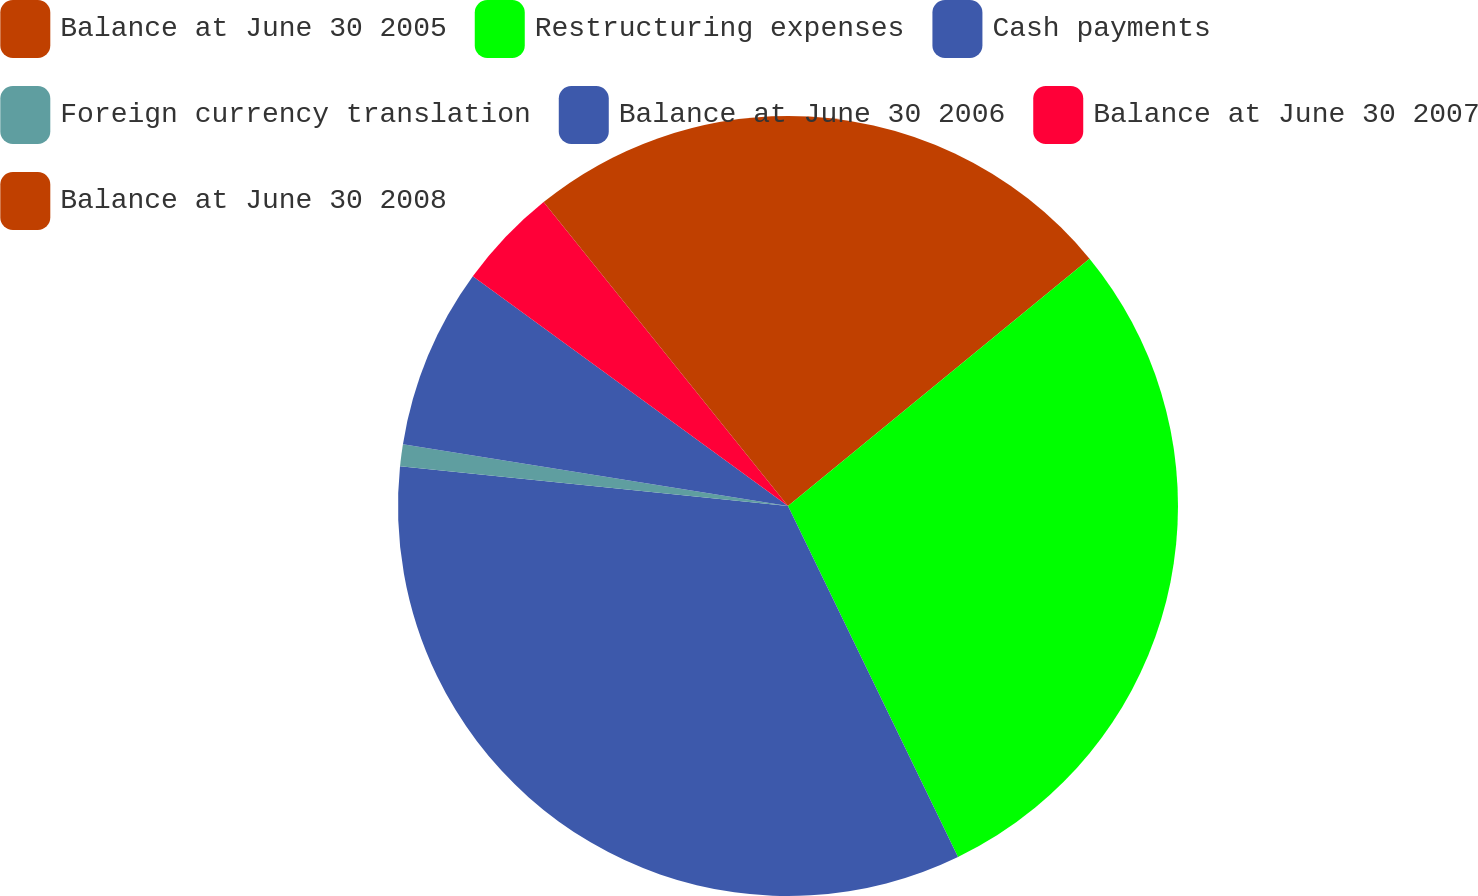Convert chart. <chart><loc_0><loc_0><loc_500><loc_500><pie_chart><fcel>Balance at June 30 2005<fcel>Restructuring expenses<fcel>Cash payments<fcel>Foreign currency translation<fcel>Balance at June 30 2006<fcel>Balance at June 30 2007<fcel>Balance at June 30 2008<nl><fcel>14.07%<fcel>28.76%<fcel>33.81%<fcel>0.91%<fcel>7.49%<fcel>4.2%<fcel>10.78%<nl></chart> 